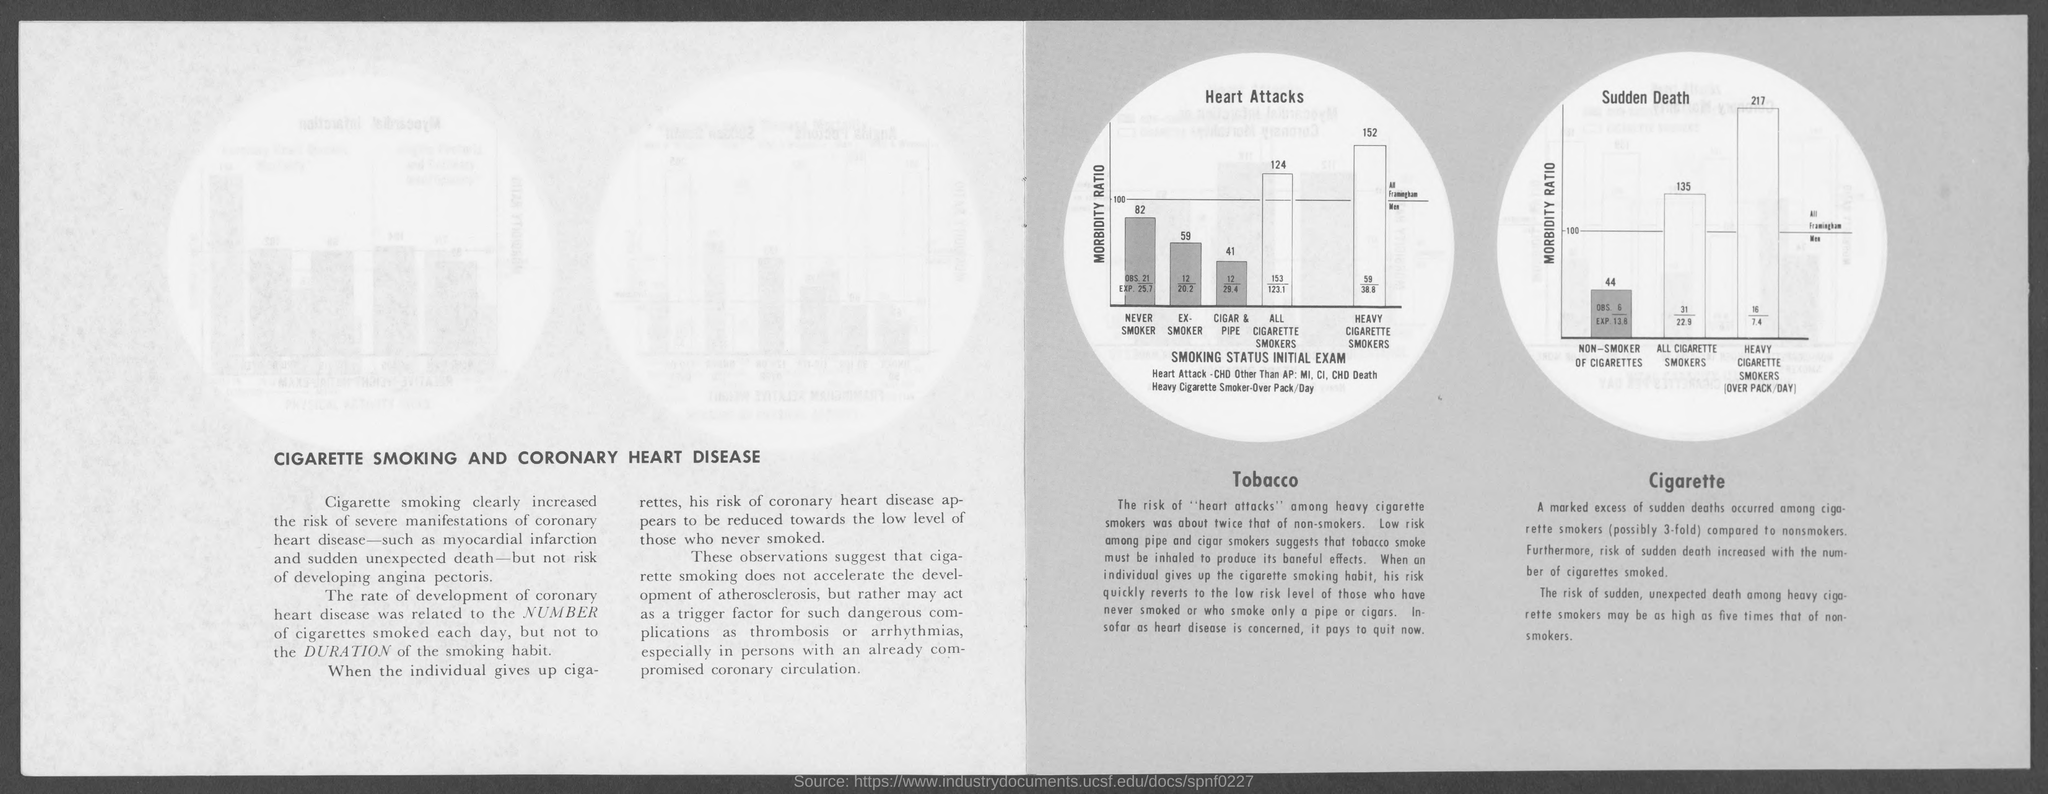Outline some significant characteristics in this image. The title of the text on the left-hand side page is "Cigarette Smoking and Coronary Heart Disease. 